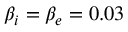Convert formula to latex. <formula><loc_0><loc_0><loc_500><loc_500>\beta _ { i } = \beta _ { e } = 0 . 0 3</formula> 